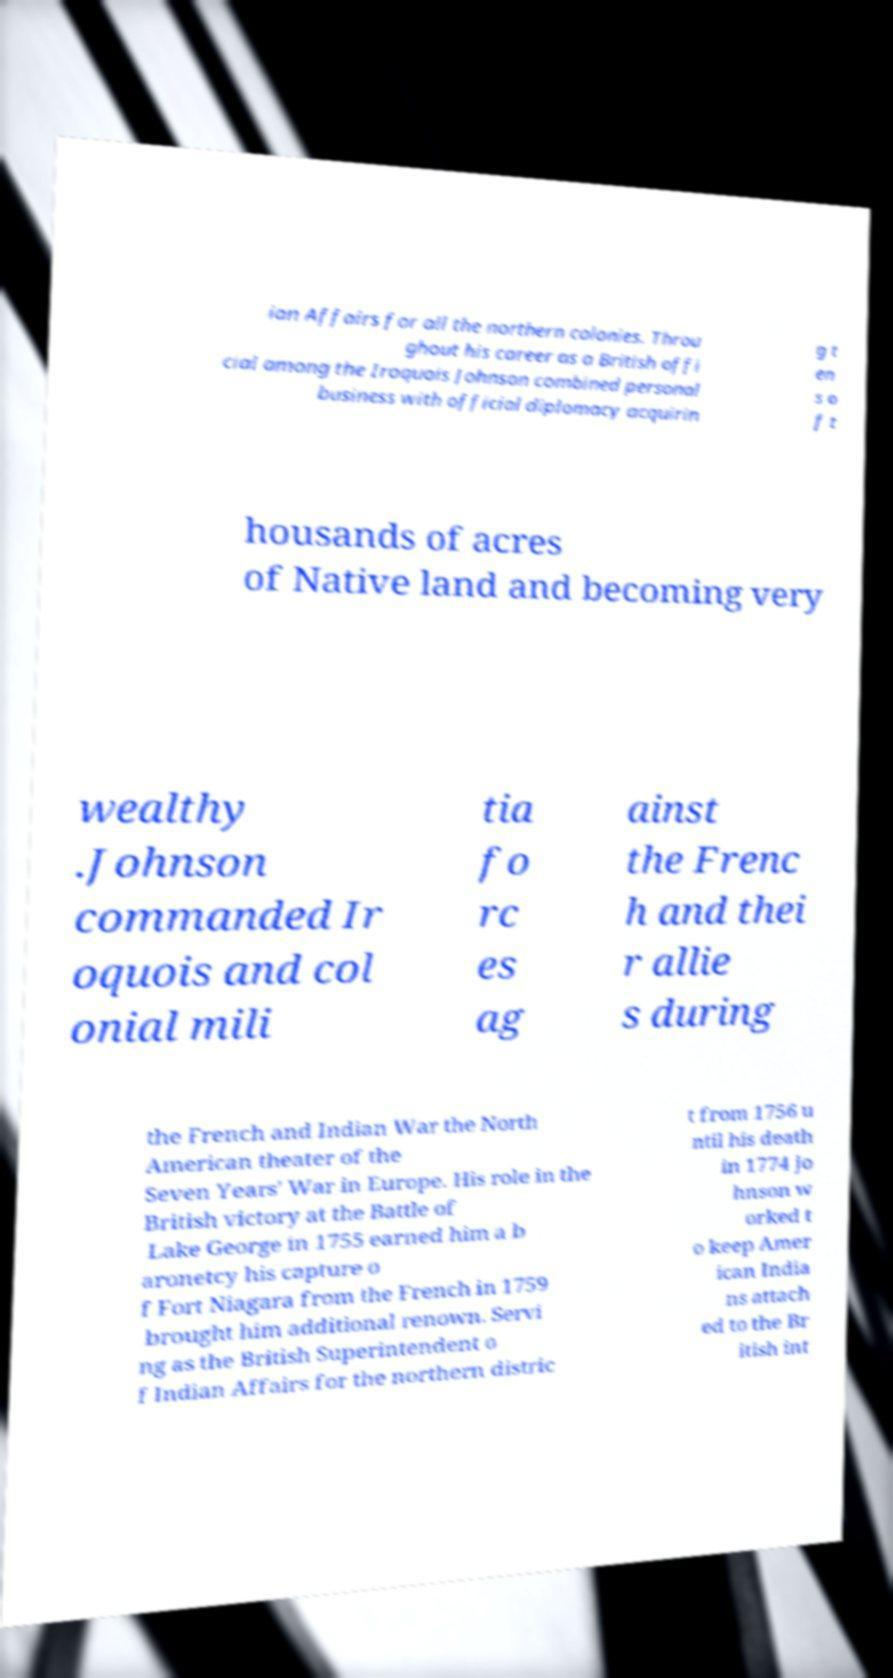Can you read and provide the text displayed in the image?This photo seems to have some interesting text. Can you extract and type it out for me? ian Affairs for all the northern colonies. Throu ghout his career as a British offi cial among the Iroquois Johnson combined personal business with official diplomacy acquirin g t en s o f t housands of acres of Native land and becoming very wealthy .Johnson commanded Ir oquois and col onial mili tia fo rc es ag ainst the Frenc h and thei r allie s during the French and Indian War the North American theater of the Seven Years' War in Europe. His role in the British victory at the Battle of Lake George in 1755 earned him a b aronetcy his capture o f Fort Niagara from the French in 1759 brought him additional renown. Servi ng as the British Superintendent o f Indian Affairs for the northern distric t from 1756 u ntil his death in 1774 Jo hnson w orked t o keep Amer ican India ns attach ed to the Br itish int 